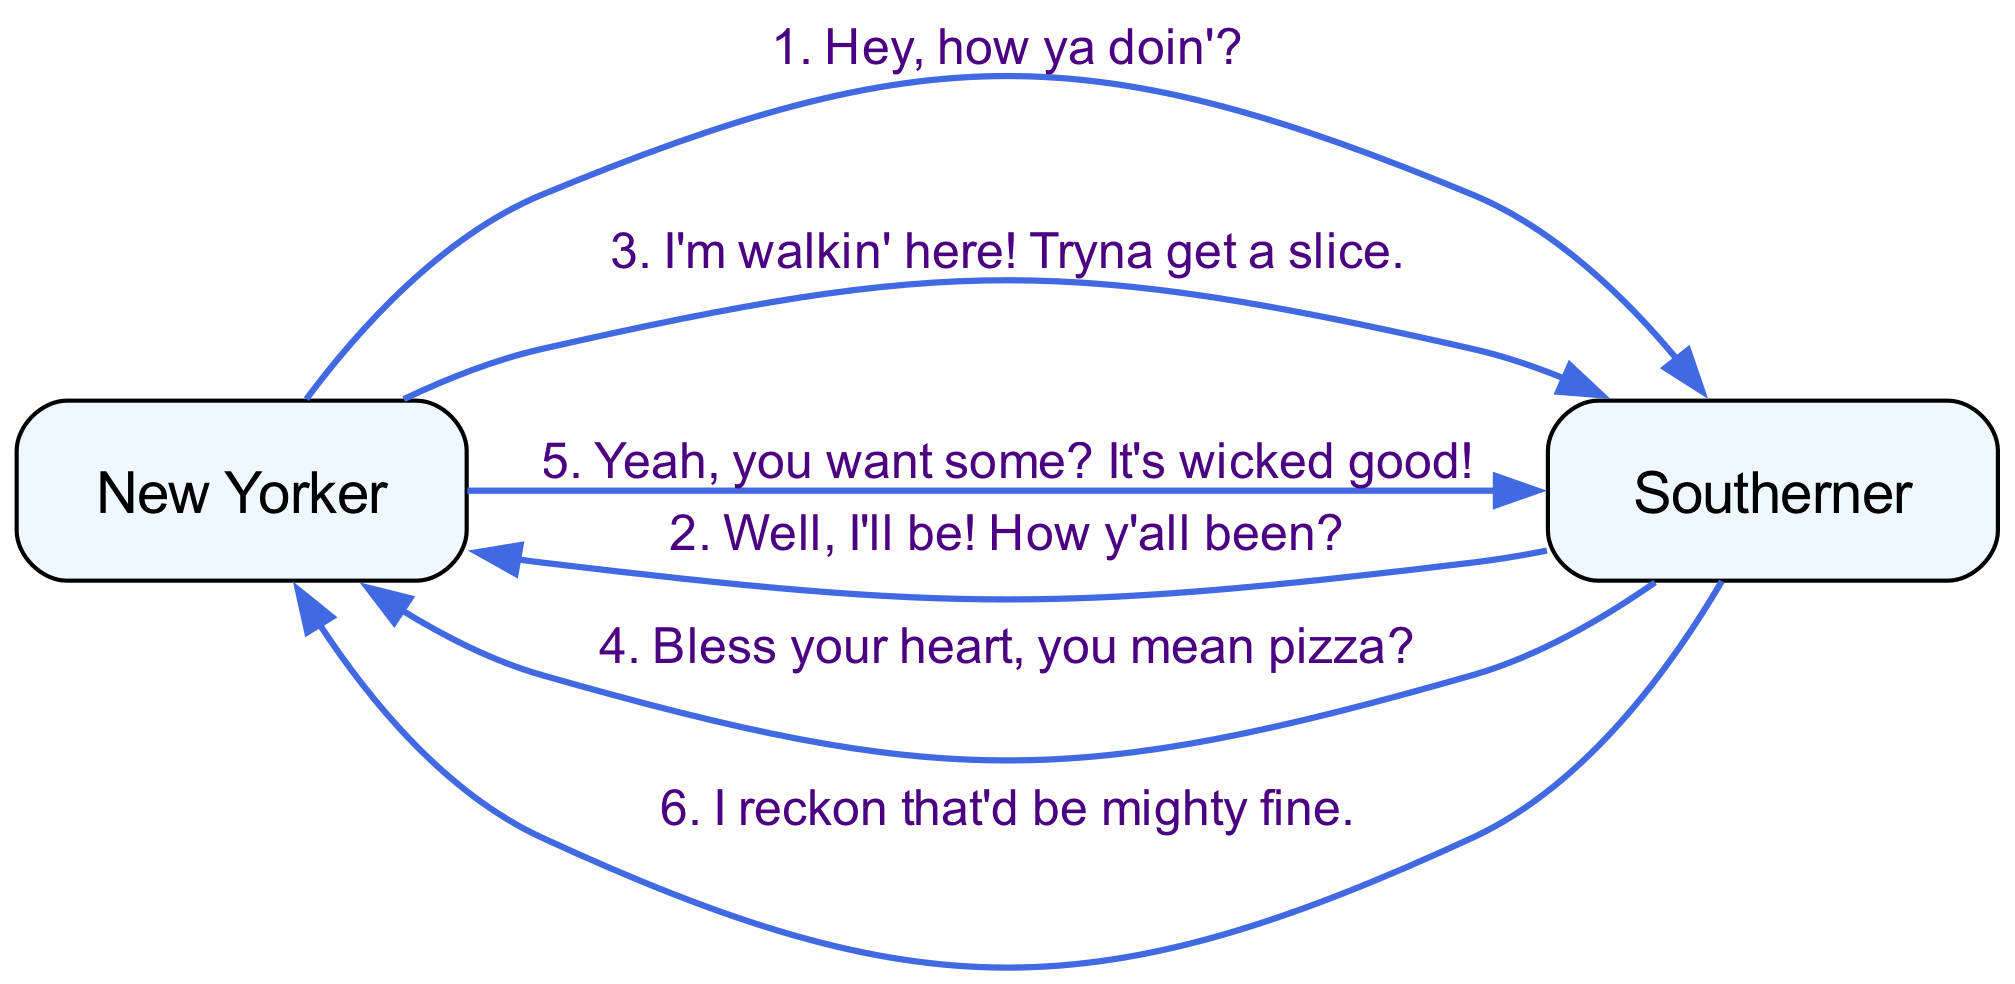What are the names of the participants in the conversation? The diagram lists two participants: "New Yorker" and "Southerner".
Answer: New Yorker, Southerner How many interactions are illustrated in the diagram? There are six interactions shown between the two participants, as indicated by the number of edges.
Answer: 6 What is the third message in the conversation? The third message from the "New Yorker" to the "Southerner" is "I'm walkin' here! Tryna get a slice." which is clearly labeled as the third edge.
Answer: I'm walkin' here! Tryna get a slice Which participant expresses a desire for pizza? The "Southerner" expresses this understanding with their response "Bless your heart, you mean pizza?", indicating they recognized the "New Yorker" was referring to pizza.
Answer: Southerner Who initiates the conversation? The first message is sent from the "New Yorker" to the "Southerner", indicating that the "New Yorker" is the one to initiate the conversation.
Answer: New Yorker What is the sentiment expressed by the "Southerner" towards the "New Yorker"'s offer? The "Southerner" responds positively with "I reckon that'd be mighty fine", which implies a good sentiment towards the offer of pizza.
Answer: Mighty fine Which interaction is the last one in the sequence? The last interaction shown in the diagram is from "Southerner" to "New Yorker", where the "Southerner" expresses willingness to have pizza, indicating this is the final response in the sequence.
Answer: I reckon that'd be mighty fine What phrase does the "New Yorker" use to emphasize their offer? The "New Yorker" uses the phrase "It's wicked good!" to emphasize the quality of their offer, which is clearly shown in the messaging interaction.
Answer: It's wicked good! 